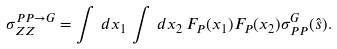Convert formula to latex. <formula><loc_0><loc_0><loc_500><loc_500>\sigma _ { Z Z } ^ { P P \rightarrow G } = \int \, d x _ { 1 } \, \int \, d x _ { 2 } \, F _ { P } ( x _ { 1 } ) F _ { P } ( x _ { 2 } ) \sigma _ { P P } ^ { G } ( \hat { s } ) .</formula> 